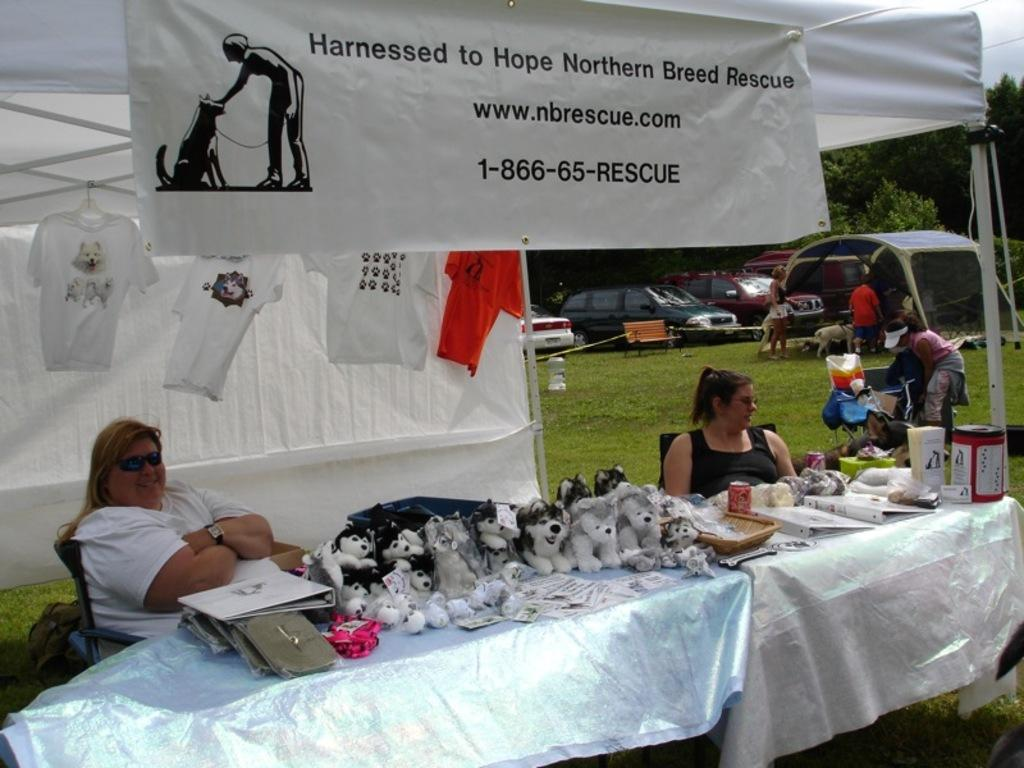How many people are in the image? There are two women in the image. What are the women doing in the image? The women are sitting in chairs. Where are the chairs located? The chairs are at a table. What objects can be seen on the table? There are dolls on the table. Can you see any mice running around on the table in the image? There are no mice present in the image; it only shows two women sitting at a table with dolls. 